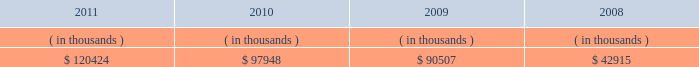System energy resources , inc .
Management 2019s financial discussion and analysis sources of capital system energy 2019s sources to meet its capital requirements include : internally generated funds ; cash on hand ; debt issuances ; and bank financing under new or existing facilities .
System energy may refinance , redeem , or otherwise retire debt prior to maturity , to the extent market conditions and interest and dividend rates are favorable .
All debt and common stock issuances by system energy require prior regulatory approval .
Debt issuances are also subject to issuance tests set forth in its bond indentures and other agreements .
System energy has sufficient capacity under these tests to meet its foreseeable capital needs .
In february 2012 , system energy vie issued $ 50 million of 4.02% ( 4.02 % ) series h notes due february 2017 .
System energy used the proceeds to purchase additional nuclear fuel .
System energy has obtained a short-term borrowing authorization from the ferc under which it may borrow , through october 2013 , up to the aggregate amount , at any one time outstanding , of $ 200 million .
See note 4 to the financial statements for further discussion of system energy 2019s short-term borrowing limits .
System energy has also obtained an order from the ferc authorizing long-term securities issuances .
The current long-term authorization extends through july 2013 .
System energy 2019s receivables from the money pool were as follows as of december 31 for each of the following years: .
See note 4 to the financial statements for a description of the money pool .
Nuclear matters system energy owns and operates grand gulf .
System energy is , therefore , subject to the risks related to owning and operating a nuclear plant .
These include risks from the use , storage , handling and disposal of high- level and low-level radioactive materials , regulatory requirement changes , including changes resulting from events at other plants , limitations on the amounts and types of insurance commercially available for losses in connection with nuclear operations , and technological and financial uncertainties related to decommissioning nuclear plants at the end of their licensed lives , including the sufficiency of funds in decommissioning trusts .
In the event of an unanticipated early shutdown of grand gulf , system energy may be required to provide additional funds or credit support to satisfy regulatory requirements for decommissioning .
After the nuclear incident in japan resulting from the march 2011 earthquake and tsunami , the nrc established a task force to conduct a review of processes and regulations relating to nuclear facilities in the united states .
The task force issued a near term ( 90-day ) report in july 2011 that has made recommendations , which are currently being evaluated by the nrc .
It is anticipated that the nrc will issue certain orders and requests for information to nuclear plant licensees by the end of the first quarter 2012 that will begin to implement the task force 2019s recommendations .
These orders may require u.s .
Nuclear operators , including entergy , to undertake plant modifications or perform additional analyses that could , among other things , result in increased costs and capital requirements associated with operating entergy 2019s nuclear plants. .
What is the total system energy 2019s receivables from the money pool in the last three years? 
Computations: ((120424 + 97948) + 90507)
Answer: 308879.0. 